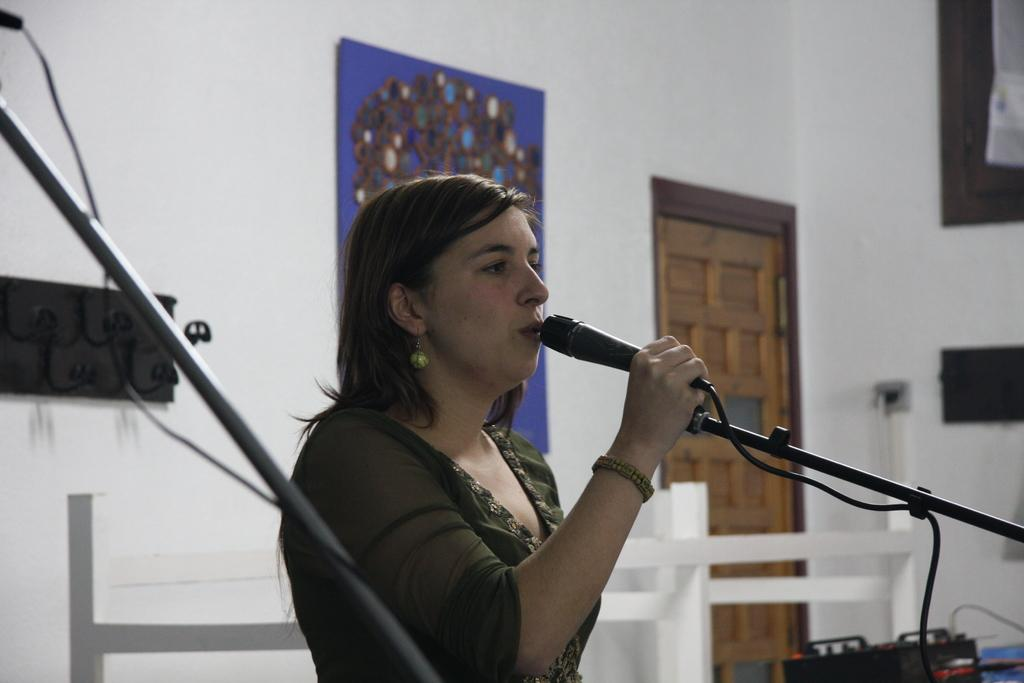Who is the main subject in the image? There is a lady in the image. What is the lady doing in the image? The lady is speaking through a mic. Can you describe the girl in the image? A girl is present in the image, and the mic is placed in front of her. What can be seen in the background of the image? There is a brown wooden door and a painting attached to the wall in the background of the image. What type of punishment is being administered to the girl in the image? There is no indication of punishment in the image; the girl is simply present with a mic in front of her. What fictional character does the lady in the image portray? The image does not depict a fictional character or any specific role; it simply shows a lady speaking through a mic. 